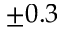<formula> <loc_0><loc_0><loc_500><loc_500>\pm 0 . 3</formula> 